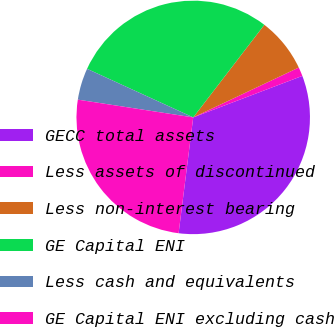Convert chart. <chart><loc_0><loc_0><loc_500><loc_500><pie_chart><fcel>GECC total assets<fcel>Less assets of discontinued<fcel>Less non-interest bearing<fcel>GE Capital ENI<fcel>Less cash and equivalents<fcel>GE Capital ENI excluding cash<nl><fcel>32.78%<fcel>1.24%<fcel>7.55%<fcel>28.59%<fcel>4.4%<fcel>25.43%<nl></chart> 